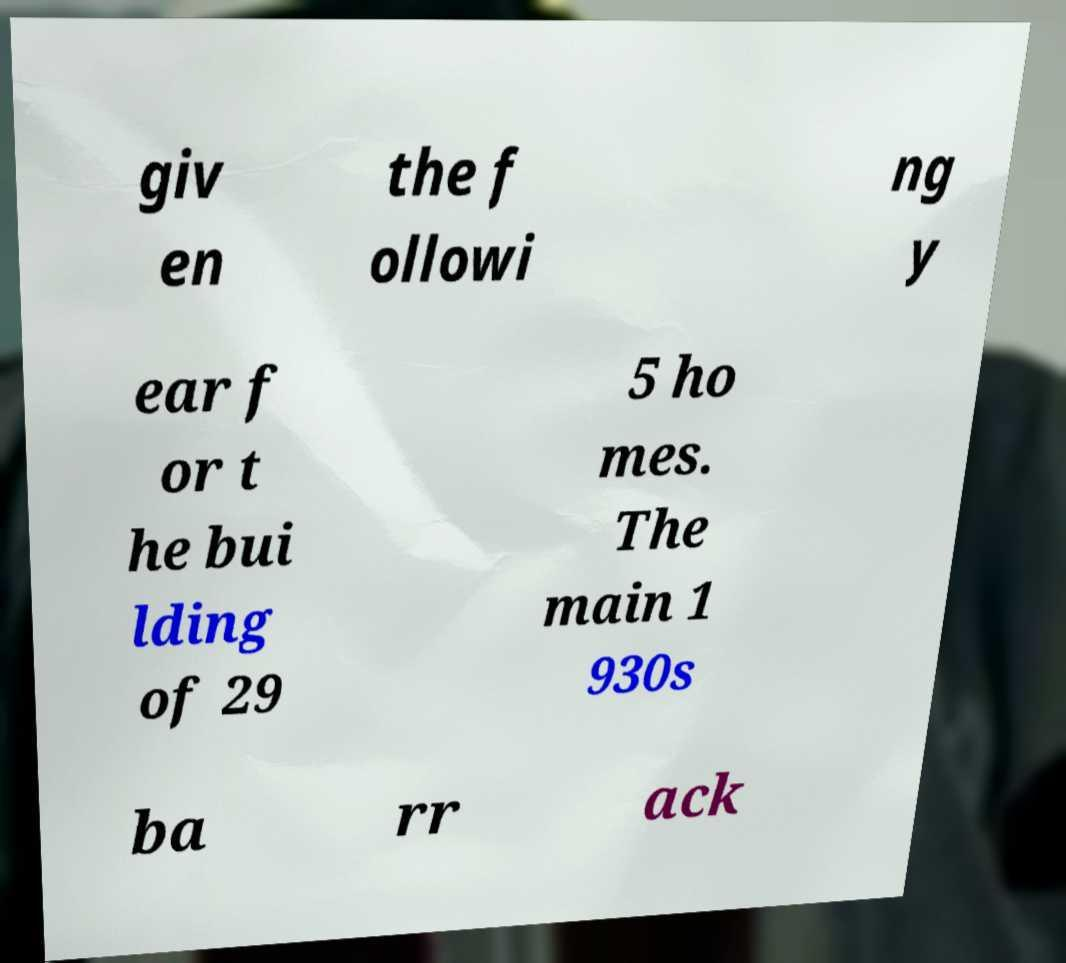Could you assist in decoding the text presented in this image and type it out clearly? giv en the f ollowi ng y ear f or t he bui lding of 29 5 ho mes. The main 1 930s ba rr ack 